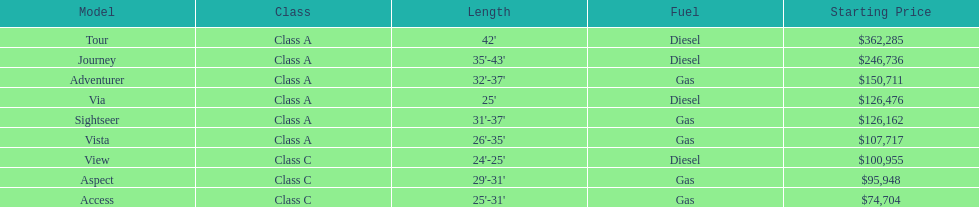What is the extent of the aspect? 29'-31'. Would you be able to parse every entry in this table? {'header': ['Model', 'Class', 'Length', 'Fuel', 'Starting Price'], 'rows': [['Tour', 'Class A', "42'", 'Diesel', '$362,285'], ['Journey', 'Class A', "35'-43'", 'Diesel', '$246,736'], ['Adventurer', 'Class A', "32'-37'", 'Gas', '$150,711'], ['Via', 'Class A', "25'", 'Diesel', '$126,476'], ['Sightseer', 'Class A', "31'-37'", 'Gas', '$126,162'], ['Vista', 'Class A', "26'-35'", 'Gas', '$107,717'], ['View', 'Class C', "24'-25'", 'Diesel', '$100,955'], ['Aspect', 'Class C', "29'-31'", 'Gas', '$95,948'], ['Access', 'Class C', "25'-31'", 'Gas', '$74,704']]} 